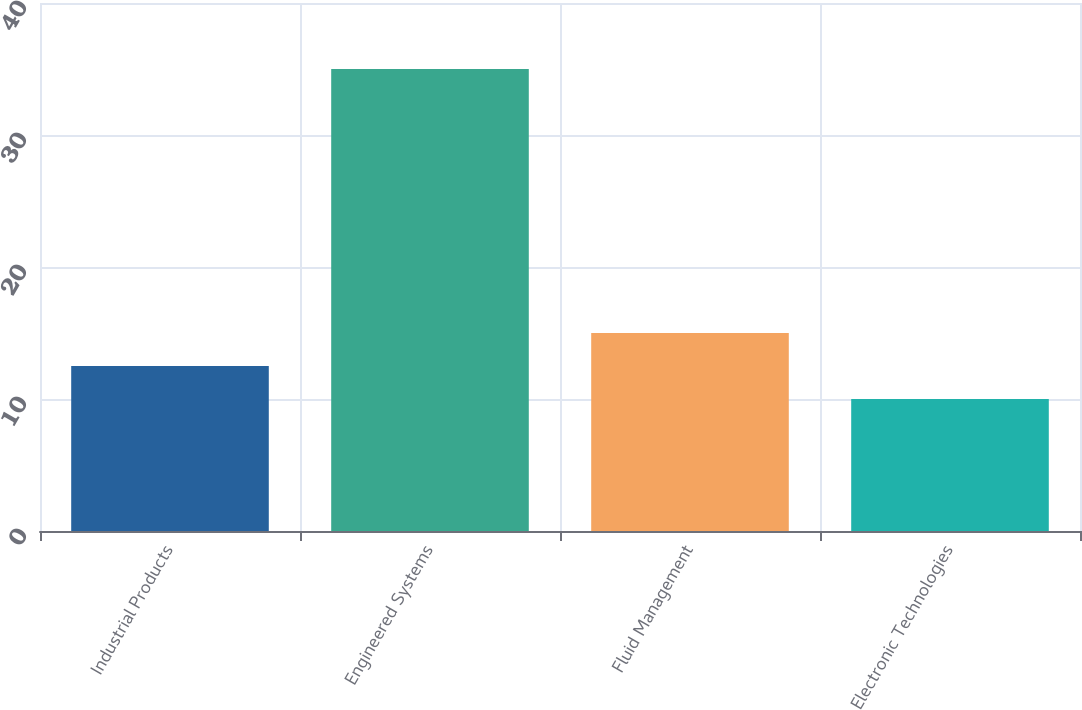<chart> <loc_0><loc_0><loc_500><loc_500><bar_chart><fcel>Industrial Products<fcel>Engineered Systems<fcel>Fluid Management<fcel>Electronic Technologies<nl><fcel>12.5<fcel>35<fcel>15<fcel>10<nl></chart> 